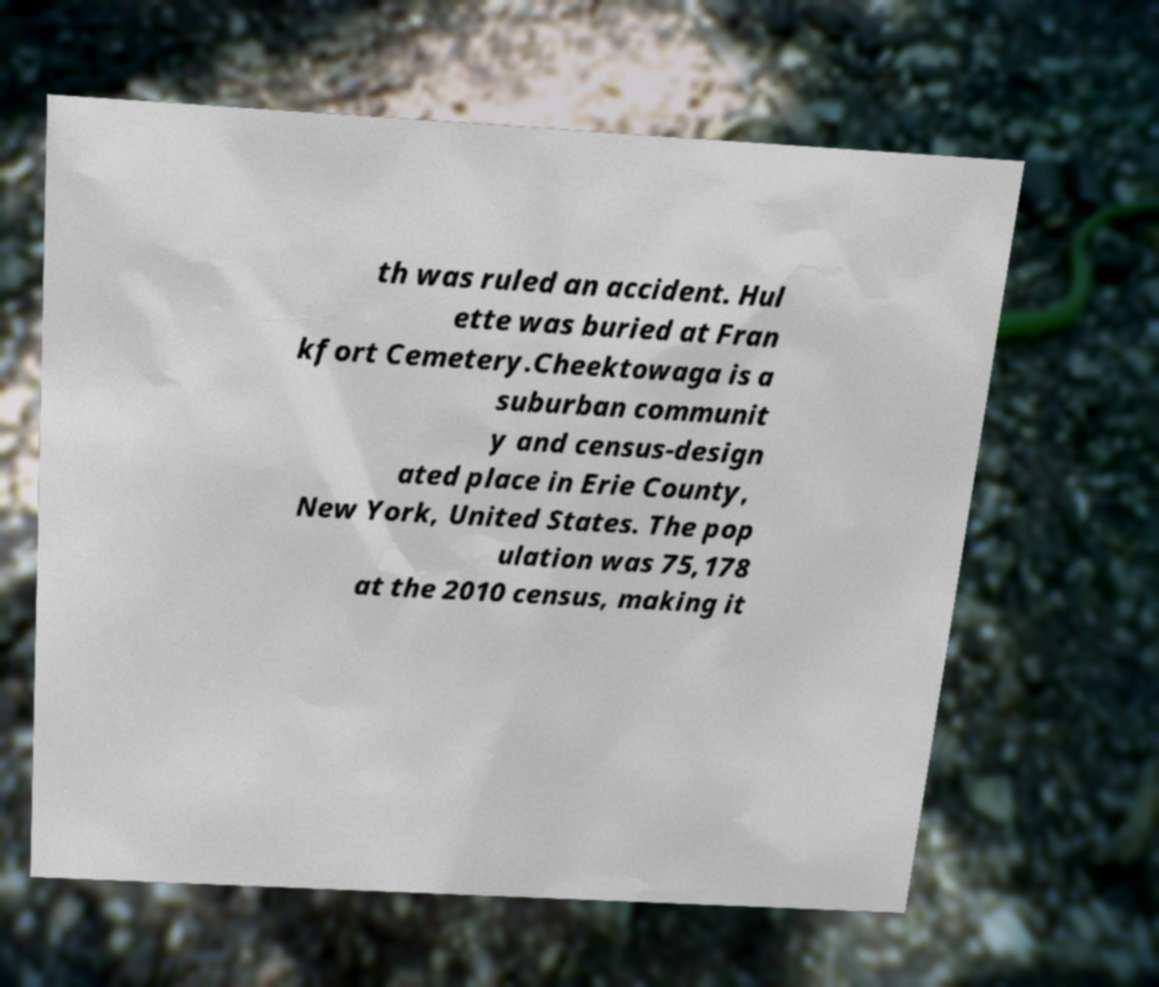Can you read and provide the text displayed in the image?This photo seems to have some interesting text. Can you extract and type it out for me? th was ruled an accident. Hul ette was buried at Fran kfort Cemetery.Cheektowaga is a suburban communit y and census-design ated place in Erie County, New York, United States. The pop ulation was 75,178 at the 2010 census, making it 